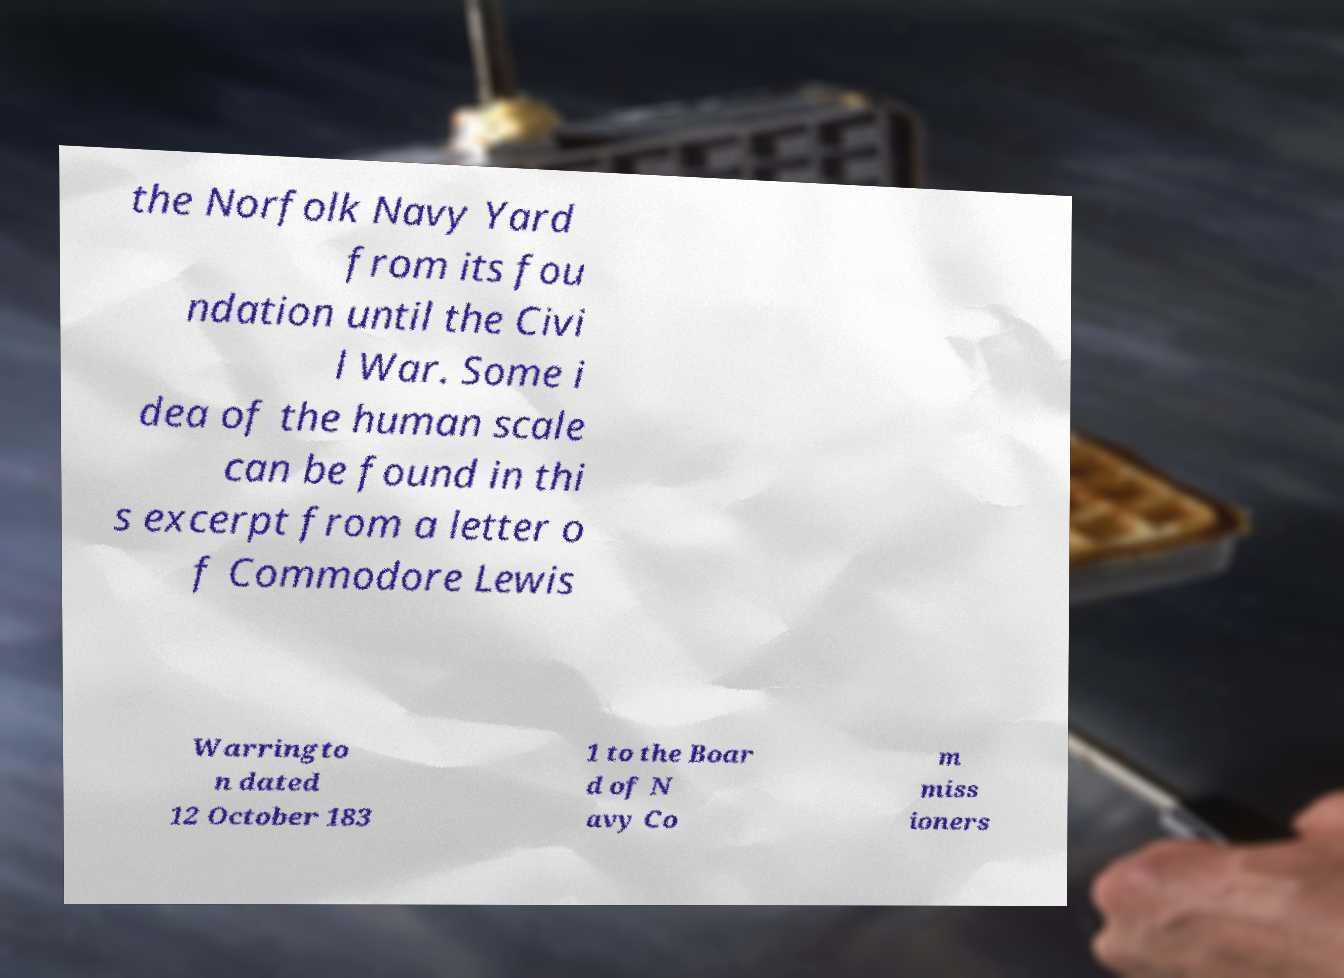Could you assist in decoding the text presented in this image and type it out clearly? the Norfolk Navy Yard from its fou ndation until the Civi l War. Some i dea of the human scale can be found in thi s excerpt from a letter o f Commodore Lewis Warringto n dated 12 October 183 1 to the Boar d of N avy Co m miss ioners 